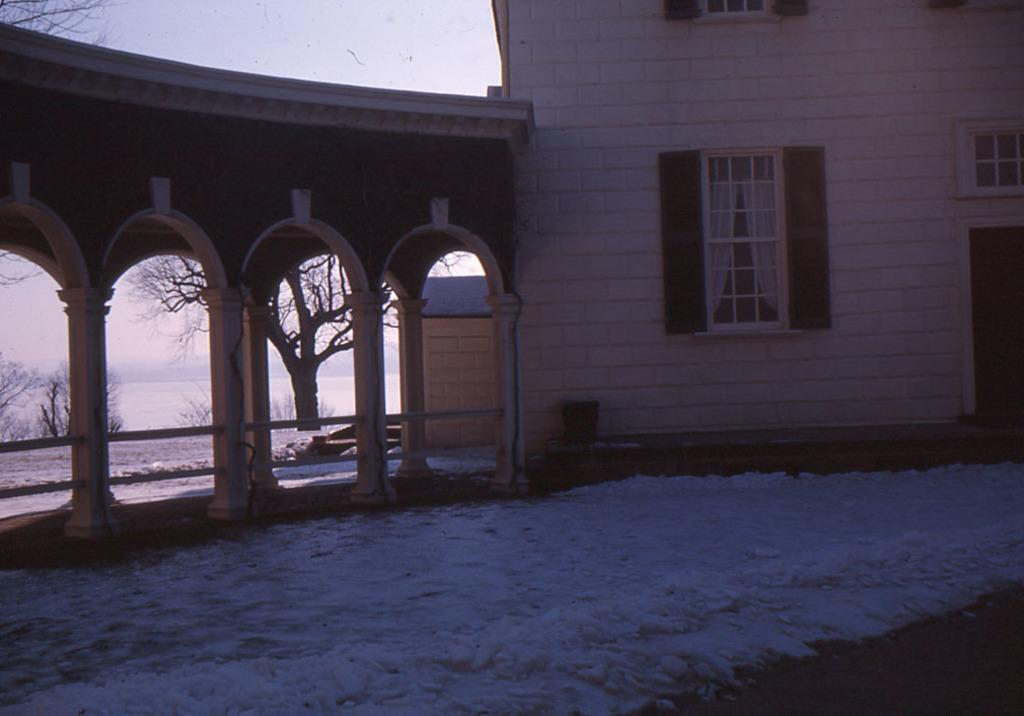What type of structures are present in the image? There are buildings with windows in the image. What architectural features can be seen on the buildings? The buildings have pillars. What can be seen in the background of the image? There are trees, water, and the sky visible in the background of the image. Can you tell me how many nerves are visible in the image? There are no nerves present in the image; it features buildings, trees, water, and the sky. Is there a girl visible in the image? There is no girl present in the image. 